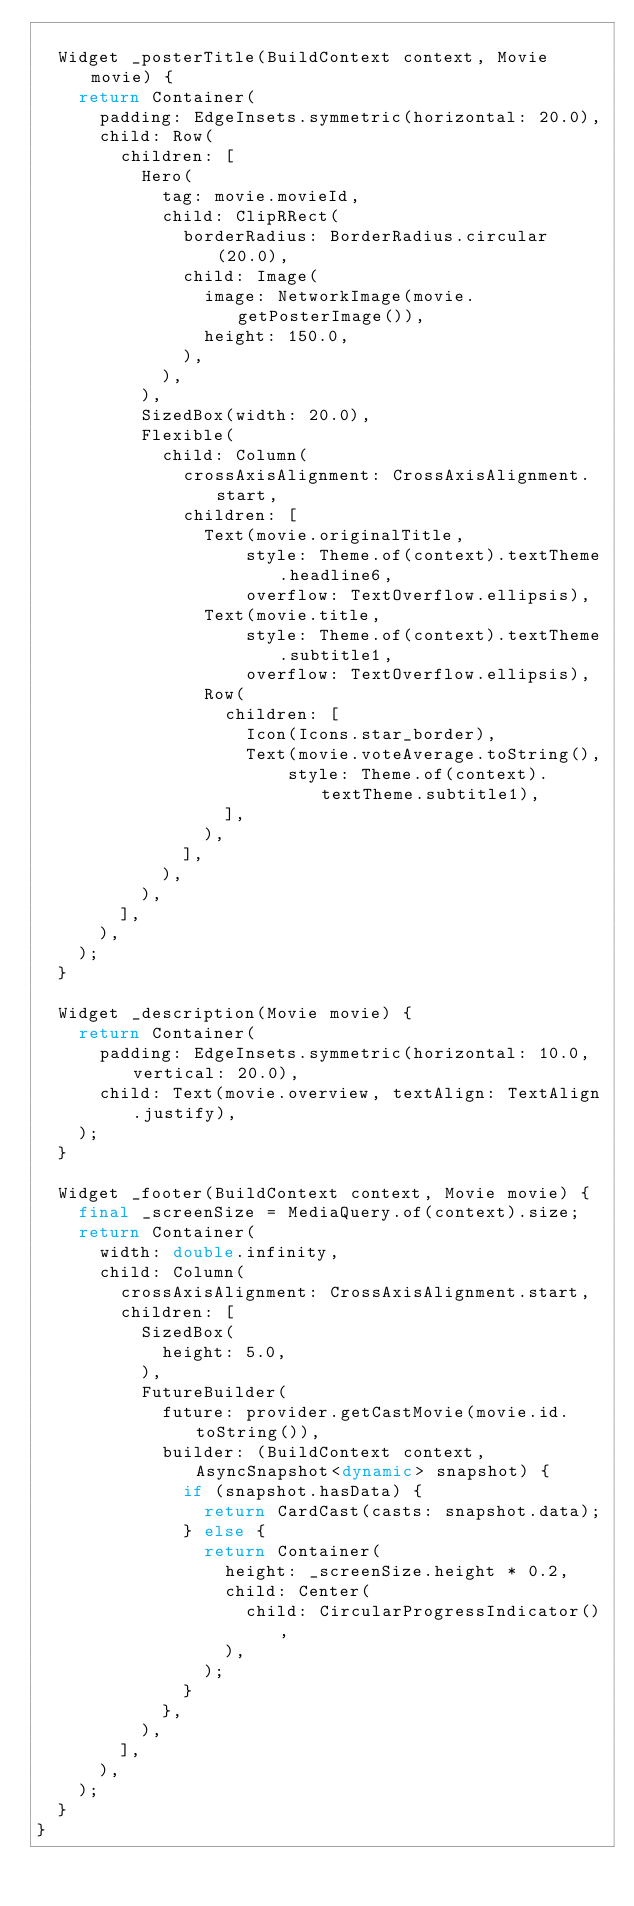Convert code to text. <code><loc_0><loc_0><loc_500><loc_500><_Dart_>
  Widget _posterTitle(BuildContext context, Movie movie) {
    return Container(
      padding: EdgeInsets.symmetric(horizontal: 20.0),
      child: Row(
        children: [
          Hero(
            tag: movie.movieId,
            child: ClipRRect(
              borderRadius: BorderRadius.circular(20.0),
              child: Image(
                image: NetworkImage(movie.getPosterImage()),
                height: 150.0,
              ),
            ),
          ),
          SizedBox(width: 20.0),
          Flexible(
            child: Column(
              crossAxisAlignment: CrossAxisAlignment.start,
              children: [
                Text(movie.originalTitle,
                    style: Theme.of(context).textTheme.headline6,
                    overflow: TextOverflow.ellipsis),
                Text(movie.title,
                    style: Theme.of(context).textTheme.subtitle1,
                    overflow: TextOverflow.ellipsis),
                Row(
                  children: [
                    Icon(Icons.star_border),
                    Text(movie.voteAverage.toString(),
                        style: Theme.of(context).textTheme.subtitle1),
                  ],
                ),
              ],
            ),
          ),
        ],
      ),
    );
  }

  Widget _description(Movie movie) {
    return Container(
      padding: EdgeInsets.symmetric(horizontal: 10.0, vertical: 20.0),
      child: Text(movie.overview, textAlign: TextAlign.justify),
    );
  }

  Widget _footer(BuildContext context, Movie movie) {
    final _screenSize = MediaQuery.of(context).size;
    return Container(
      width: double.infinity,
      child: Column(
        crossAxisAlignment: CrossAxisAlignment.start,
        children: [
          SizedBox(
            height: 5.0,
          ),
          FutureBuilder(
            future: provider.getCastMovie(movie.id.toString()),
            builder: (BuildContext context, AsyncSnapshot<dynamic> snapshot) {
              if (snapshot.hasData) {
                return CardCast(casts: snapshot.data);
              } else {
                return Container(
                  height: _screenSize.height * 0.2,
                  child: Center(
                    child: CircularProgressIndicator(),
                  ),
                );
              }
            },
          ),
        ],
      ),
    );
  }
}
</code> 